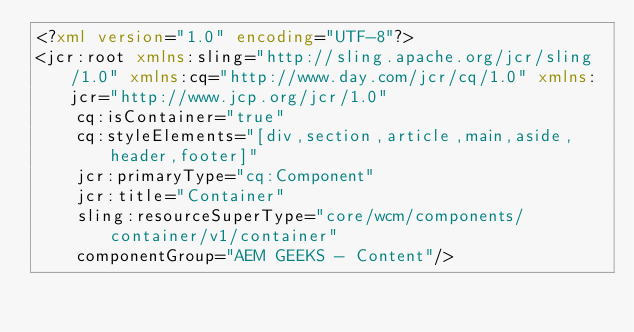<code> <loc_0><loc_0><loc_500><loc_500><_XML_><?xml version="1.0" encoding="UTF-8"?>
<jcr:root xmlns:sling="http://sling.apache.org/jcr/sling/1.0" xmlns:cq="http://www.day.com/jcr/cq/1.0" xmlns:jcr="http://www.jcp.org/jcr/1.0"
    cq:isContainer="true"
    cq:styleElements="[div,section,article,main,aside,header,footer]"
    jcr:primaryType="cq:Component"
    jcr:title="Container"
    sling:resourceSuperType="core/wcm/components/container/v1/container"
    componentGroup="AEM GEEKS - Content"/>
</code> 